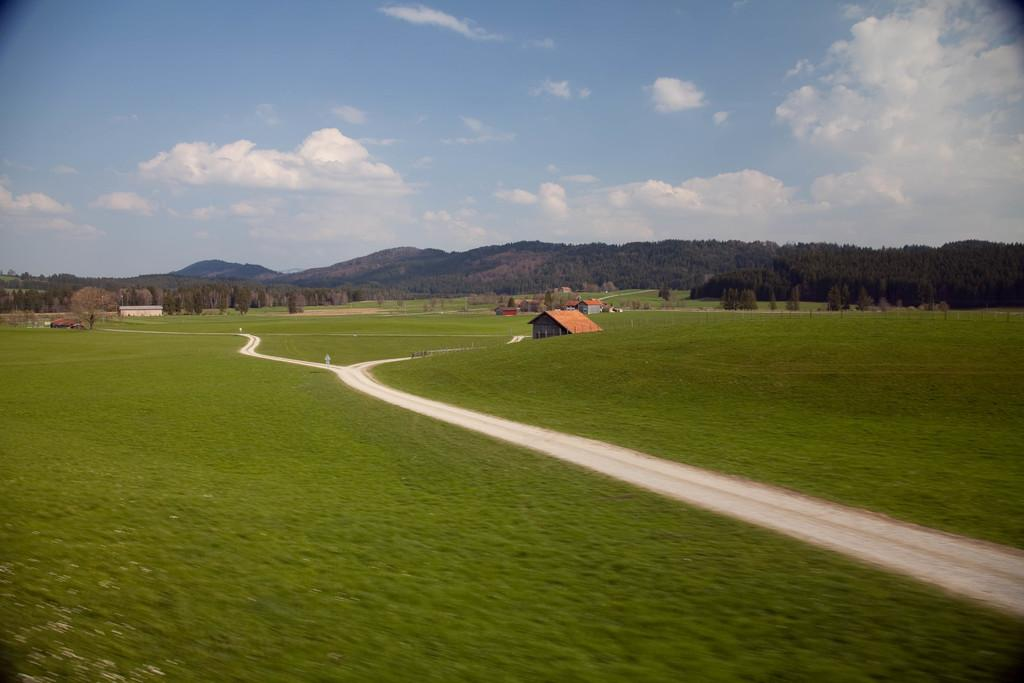What type of structures can be seen in the image? There are houses in the image. What type of vegetation is present in the image? There are trees in the image. What type of terrain is visible in the image? There are hills in the image. What type of ground cover is visible in the image? There is grass visible in the image. What type of routes are available for traversing the area in the image? There are paths in the image. What is the condition of the sky in the image? The sky is cloudy in the image. What type of muscle can be seen flexing in the image? There is no muscle visible in the image; it features houses, trees, hills, grass, paths, and a cloudy sky. What type of wood is used to construct the houses in the image? The image does not provide information about the materials used to construct the houses. 